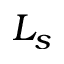<formula> <loc_0><loc_0><loc_500><loc_500>L _ { s }</formula> 